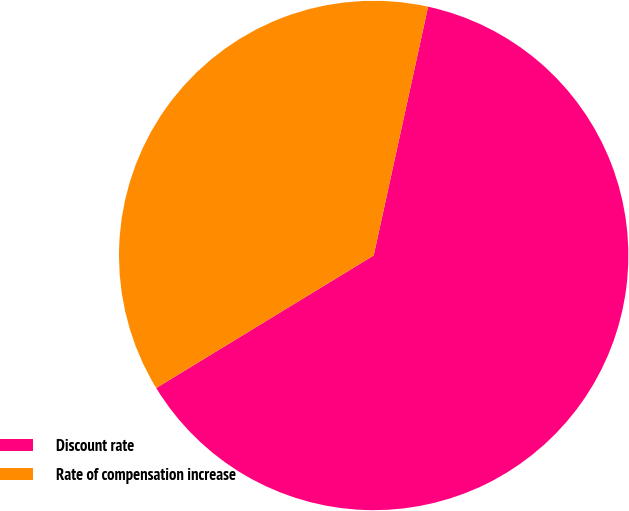<chart> <loc_0><loc_0><loc_500><loc_500><pie_chart><fcel>Discount rate<fcel>Rate of compensation increase<nl><fcel>62.86%<fcel>37.14%<nl></chart> 